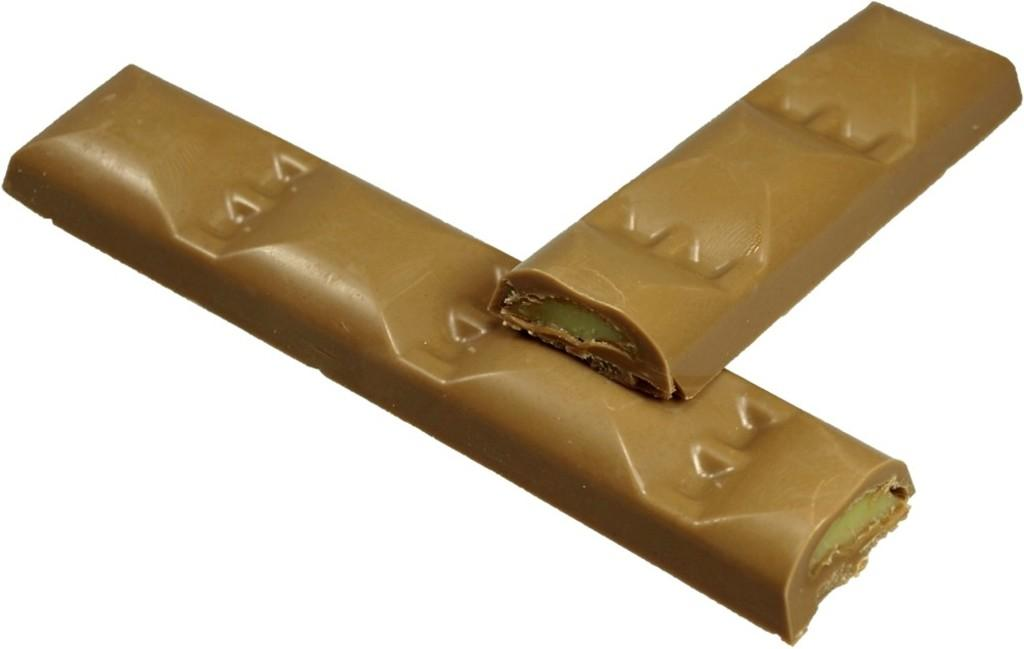What type of food items are present in the image? There are two chocolate bars in the image. What color is the background of the image? The background of the image is white. What decision is being made in the image? There is no indication of a decision being made in the image, as it only features two chocolate bars and a white background. 